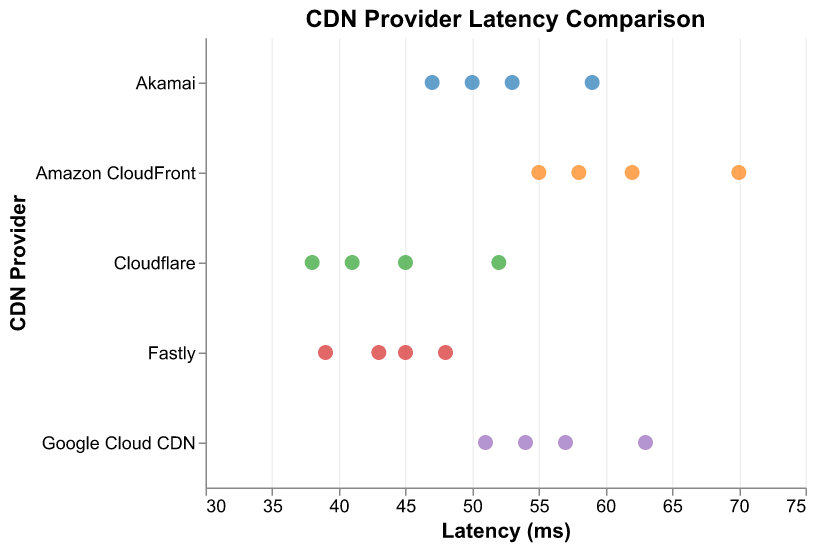What is the title of the figure? The title of the figure is placed at the top and displayed in bold font size 16. It reads "CDN Provider Latency Comparison".
Answer: CDN Provider Latency Comparison Which CDN provider has the highest latency measurement? By looking at the horizontal placement of points, the highest latency measurement is on the rightmost side of the plot. The rightmost point corresponds to Amazon CloudFront with a latency of 70 ms.
Answer: Amazon CloudFront How many data points are there for each CDN provider? Count the number of points for each CDN provider on the y-axis. Each provider has exactly 4 latency data points illustrated by distinct points.
Answer: 4 What is the range of latencies for Cloudflare? The positions of the points on the x-axis for Cloudflare range from the minimum value of 38 ms to the maximum value of 52 ms.
Answer: 38 to 52 ms Which CDN provider has the lowest average latency? To determine the provider with the lowest average latency, visually estimate the central tendency of the points on the x-axis for each provider. Cloudflare has the lowest average latency as its points are closest to the left side.
Answer: Cloudflare What is the average latency of Google Cloud CDN? The latencies for Google Cloud CDN are 57, 51, 63, and 54 ms. Sum these values to get 225 ms. Divide by 4 (the number of measurements) to find the average: 225 / 4 = 56.25 ms.
Answer: 56.25 ms How does Akamai's highest latency compare to Fastly's highest latency? Locate the highest latency point for each provider. Akamai's highest latency is 59 ms, while Fastly's highest latency is 48 ms. Compare these two values.
Answer: Akamai's highest latency (59 ms) is higher than Fastly's (48 ms) What can you infer about the consistency of latencies among different CDN providers? Examine the spread or clustering of points for each provider. Cloudflare and Fastly have closely clustered points, indicating more consistent latencies. In contrast, Amazon CloudFront has a wider spread, indicating less consistent latencies.
Answer: Cloudflare and Fastly have more consistent latencies compared to Amazon CloudFront Which CDN providers have at least one latency measurement below 40 ms? Identify the points that fall to the left of the 40 ms mark on the x-axis. Both Cloudflare and Fastly have at least one measurement below 40 ms.
Answer: Cloudflare and Fastly What is the difference in latency between the highest value for Google Cloud CDN and the lowest value for Amazon CloudFront? The highest latency measurement for Google Cloud CDN is 63 ms, and the lowest for Amazon CloudFront is 55 ms. Subtract the latter from the former: 63 - 55 = 8 ms.
Answer: 8 ms 